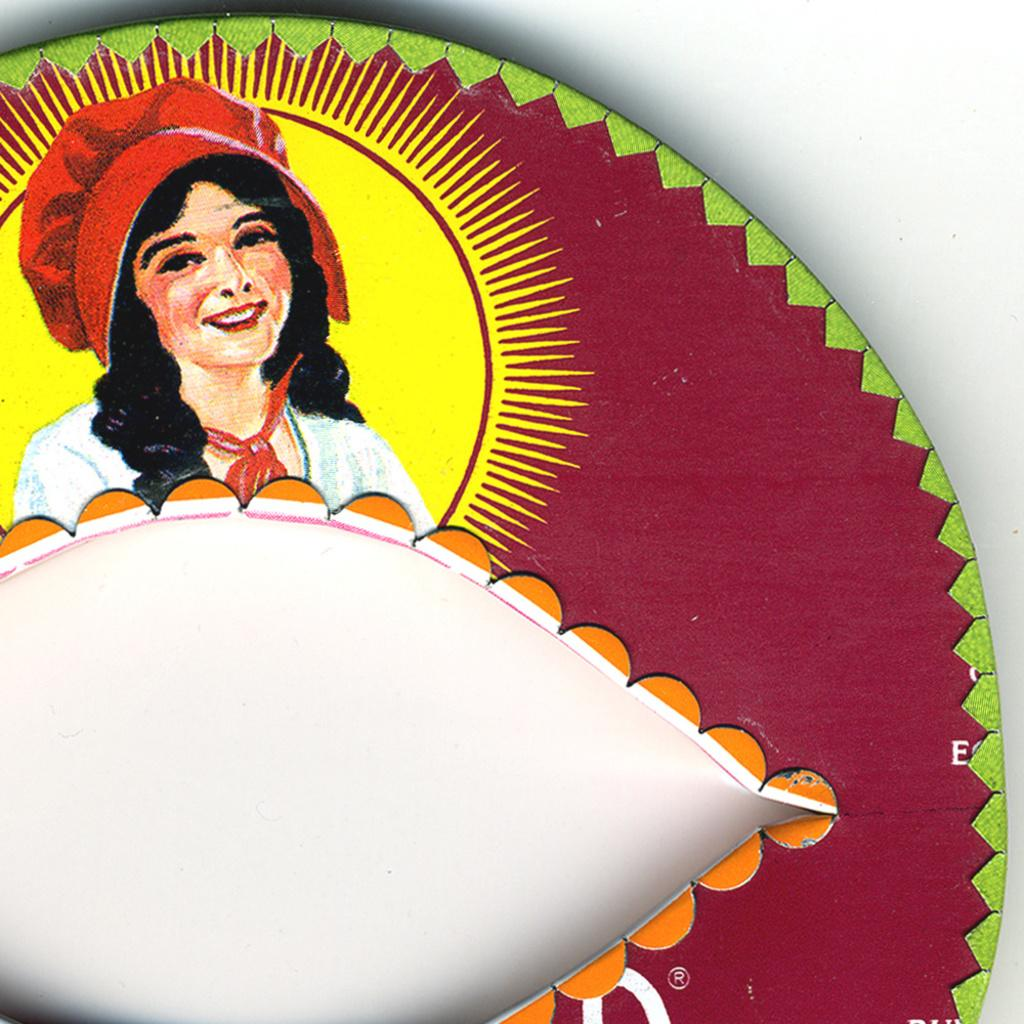What is the main subject of the painting in the image? There is a painting of a person in the image. What type of record is being played in the background of the painting? There is no record present in the painting or the image; the painting only features a person. 